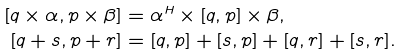Convert formula to latex. <formula><loc_0><loc_0><loc_500><loc_500>[ q \times \alpha , p \times \beta ] & = \alpha ^ { H } \times [ q , p ] \times \beta , \\ [ q + s , p + r ] & = [ q , p ] + [ s , p ] + [ q , r ] + [ s , r ] .</formula> 